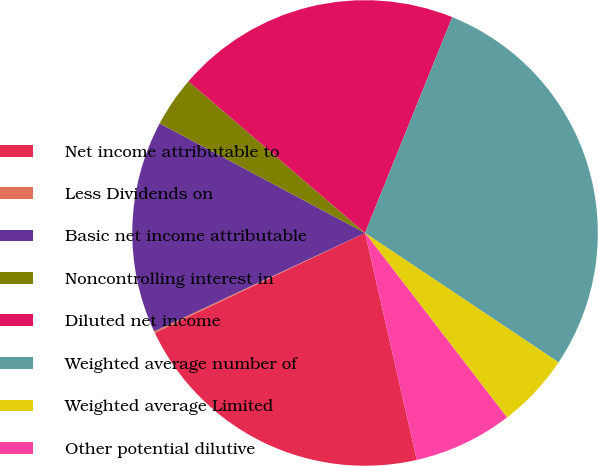<chart> <loc_0><loc_0><loc_500><loc_500><pie_chart><fcel>Net income attributable to<fcel>Less Dividends on<fcel>Basic net income attributable<fcel>Noncontrolling interest in<fcel>Diluted net income<fcel>Weighted average number of<fcel>Weighted average Limited<fcel>Other potential dilutive<nl><fcel>21.51%<fcel>0.11%<fcel>14.75%<fcel>3.49%<fcel>19.82%<fcel>28.27%<fcel>5.18%<fcel>6.87%<nl></chart> 